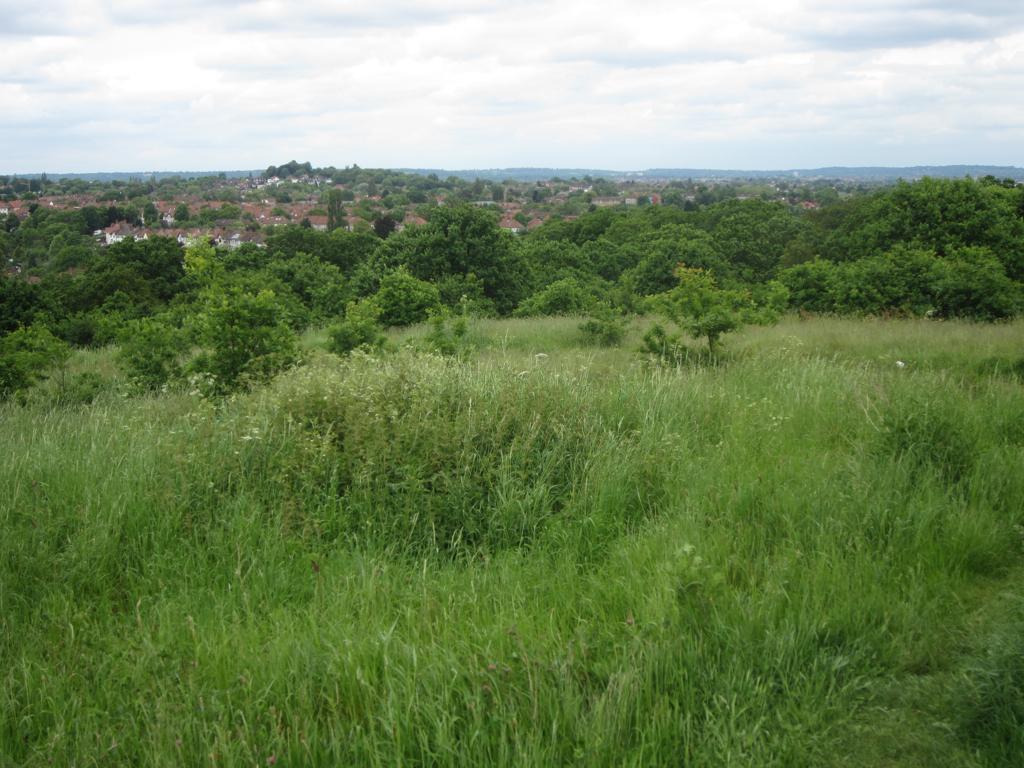Can you describe this image briefly? In this image we can see grass, trees, houses and the Sky with clouds in the background. 